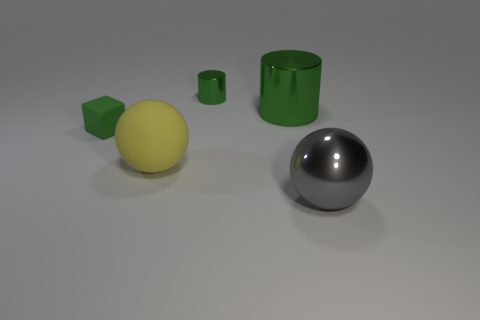The metallic thing that is in front of the large shiny thing that is behind the metallic object that is in front of the large yellow thing is what color? The metallic object in question, which is in front of a large shiny object and behind another metallic object that itself is in front of a large yellow sphere, is silver or chrome in color. This gives it a reflective surface that can mirror the environment around it, giving an impression of sleekness and modern design. 